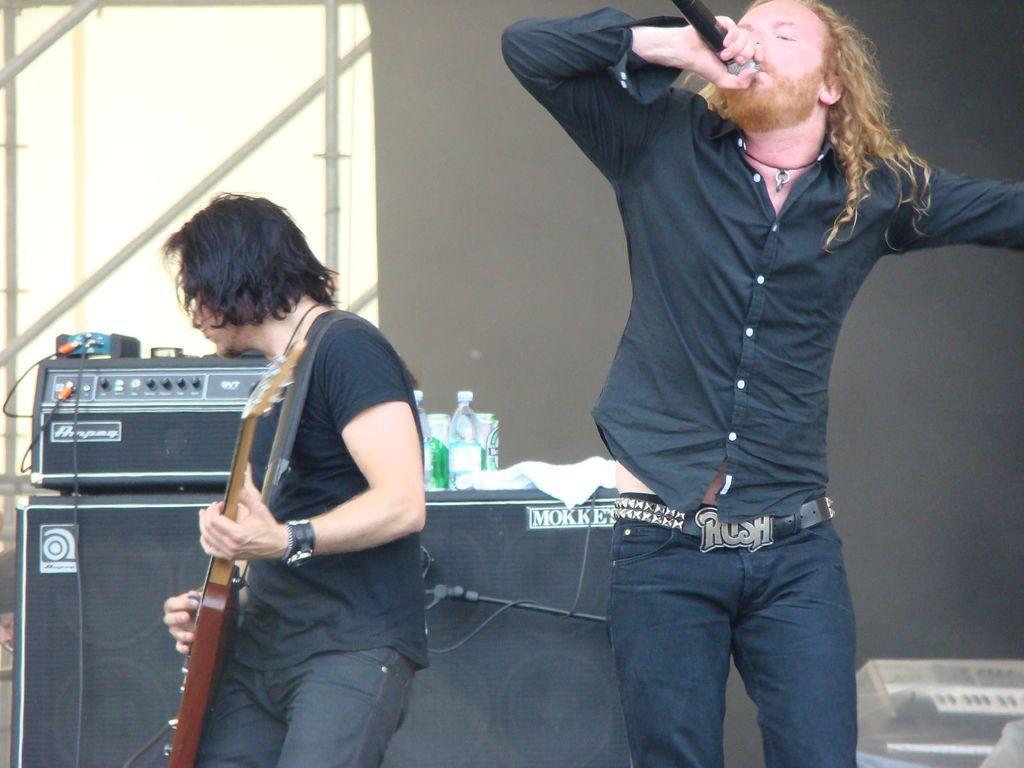How would you summarize this image in a sentence or two? There are two men in the picture. One guy is singing holding a mic in his hands and the other guy is playing guitar in his hands. In the background there are some speakers and a music operator here. We can observe a wall too. 